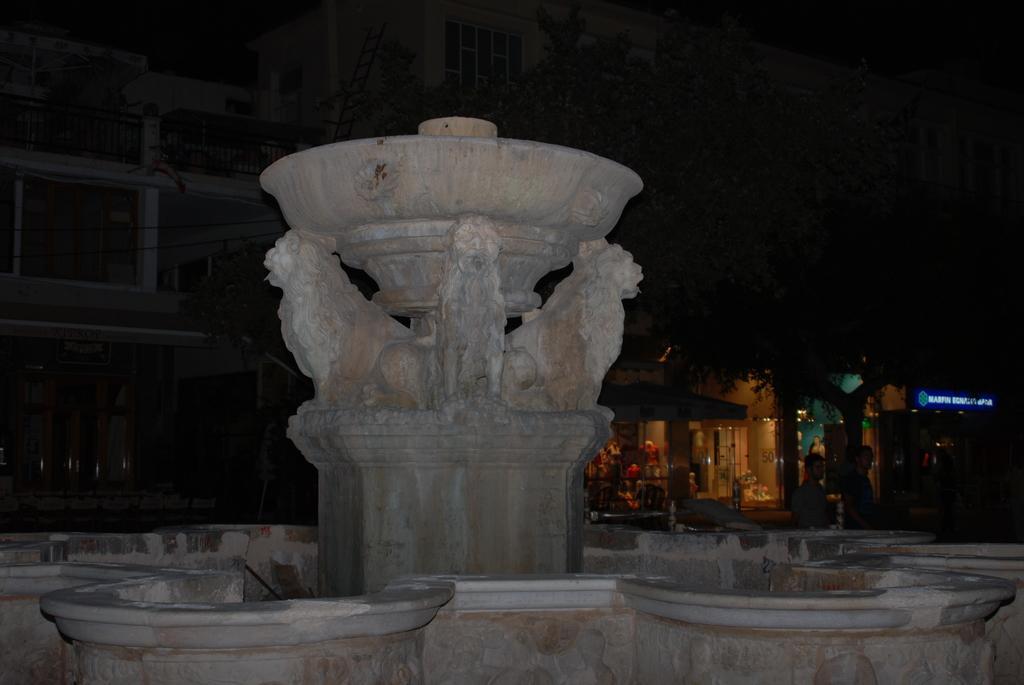In one or two sentences, can you explain what this image depicts? We can see statues on the platform and wall. In the background it is dark and we can see building, people, tree, board and few objects. 